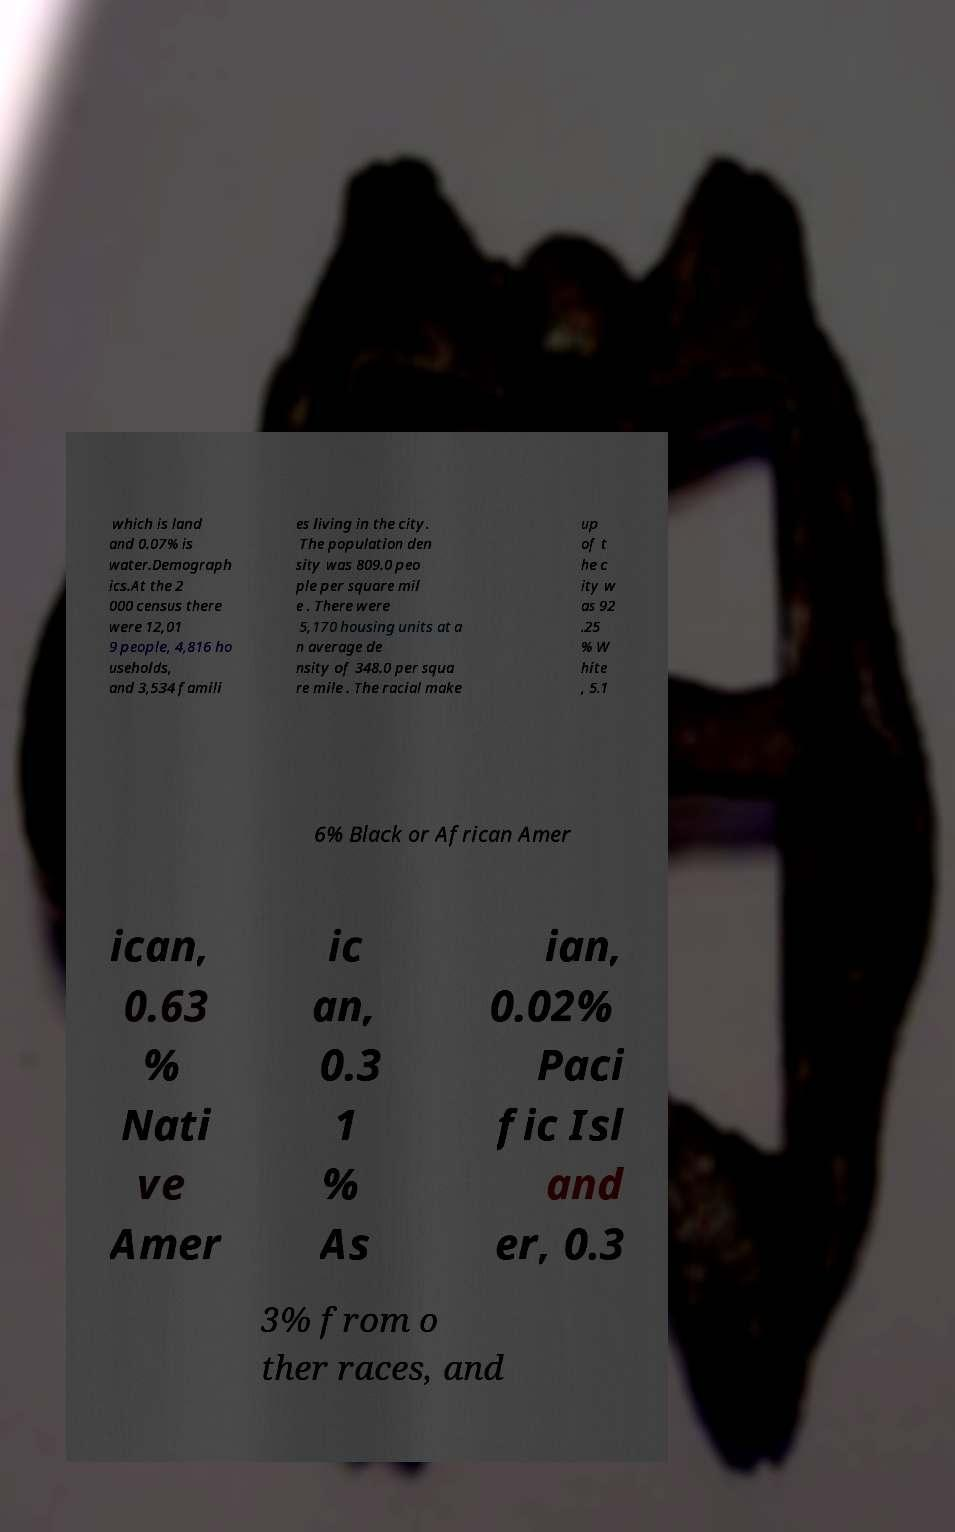Can you read and provide the text displayed in the image?This photo seems to have some interesting text. Can you extract and type it out for me? which is land and 0.07% is water.Demograph ics.At the 2 000 census there were 12,01 9 people, 4,816 ho useholds, and 3,534 famili es living in the city. The population den sity was 809.0 peo ple per square mil e . There were 5,170 housing units at a n average de nsity of 348.0 per squa re mile . The racial make up of t he c ity w as 92 .25 % W hite , 5.1 6% Black or African Amer ican, 0.63 % Nati ve Amer ic an, 0.3 1 % As ian, 0.02% Paci fic Isl and er, 0.3 3% from o ther races, and 